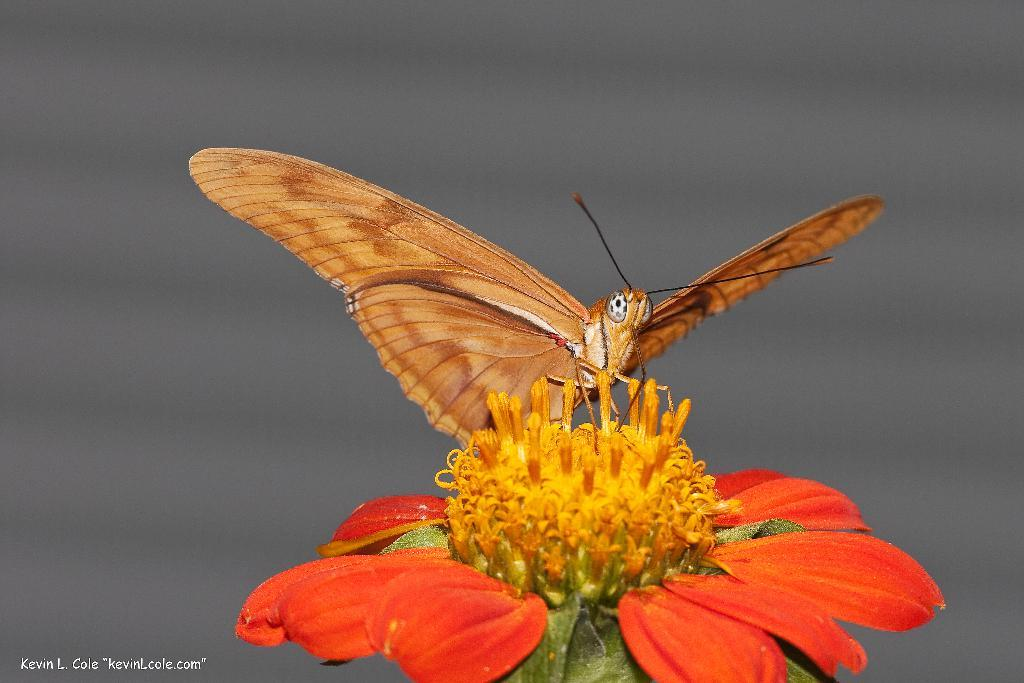What is the main subject of the image? The main subject of the image is a butterfly. Where is the butterfly located in the image? The butterfly is on a flower. What type of cap is the butterfly wearing in the image? There is no cap present in the image, as butterflies do not wear caps. What brand of toothpaste is being advertised by the butterfly in the image? There is no toothpaste or advertisement present in the image, as it features a butterfly on a flower. 